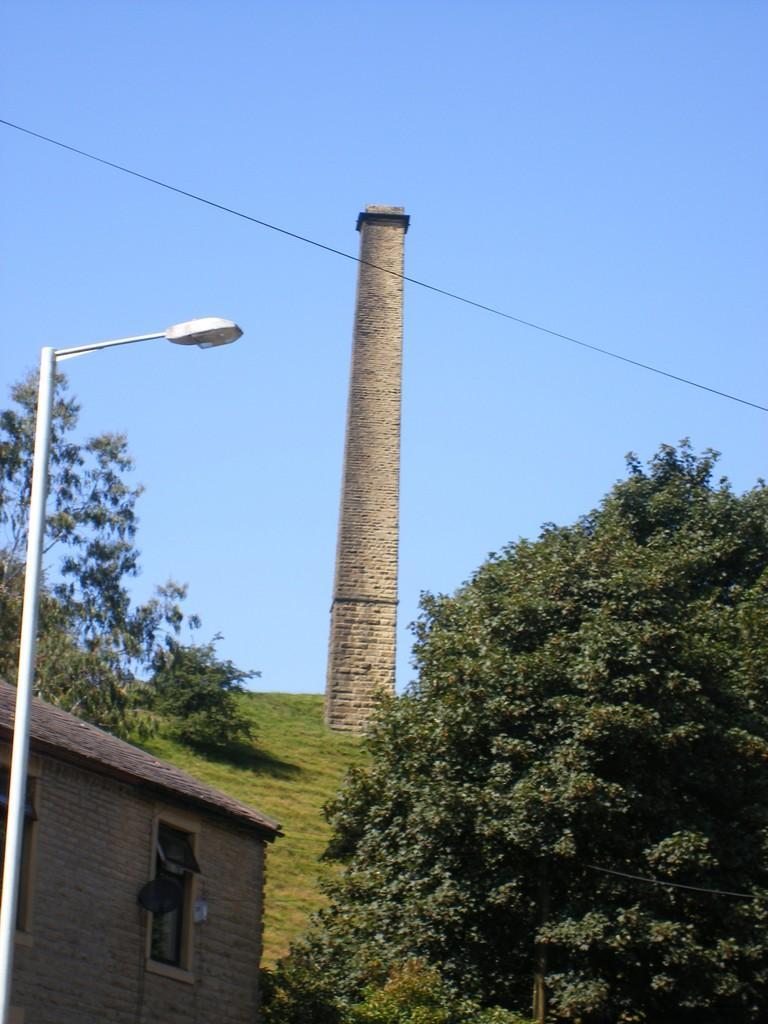Describe this image in one or two sentences. In this image we can see a tower, trees, shed, antenna, street pole, street light, cable and sky. 